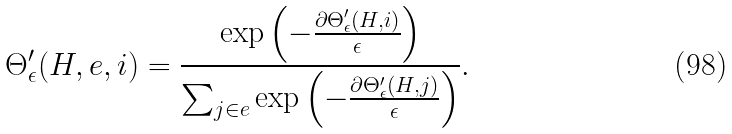Convert formula to latex. <formula><loc_0><loc_0><loc_500><loc_500>\Theta ^ { \prime } _ { \epsilon } ( H , e , i ) = \frac { \exp \left ( - \frac { \partial \Theta ^ { \prime } _ { \epsilon } ( H , i ) } { \epsilon } \right ) } { \sum _ { j \in e } \exp \left ( - \frac { \partial \Theta ^ { \prime } _ { \epsilon } ( H , j ) } { \epsilon } \right ) } .</formula> 